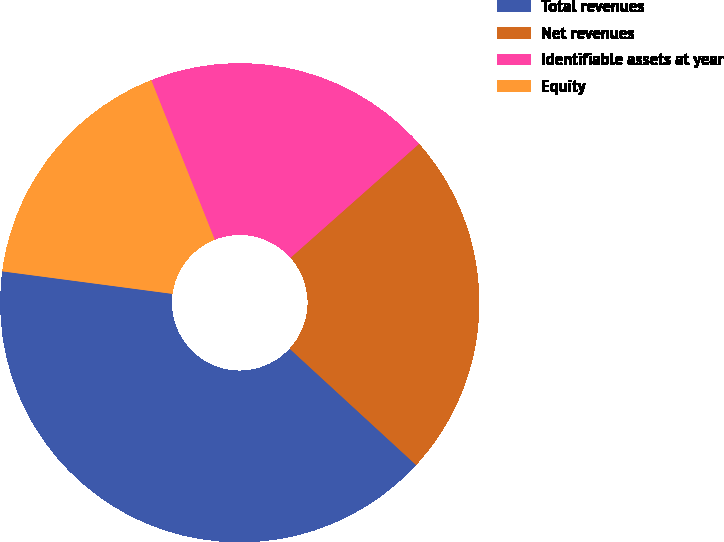Convert chart to OTSL. <chart><loc_0><loc_0><loc_500><loc_500><pie_chart><fcel>Total revenues<fcel>Net revenues<fcel>Identifiable assets at year<fcel>Equity<nl><fcel>40.26%<fcel>23.38%<fcel>19.48%<fcel>16.88%<nl></chart> 